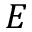Convert formula to latex. <formula><loc_0><loc_0><loc_500><loc_500>E</formula> 